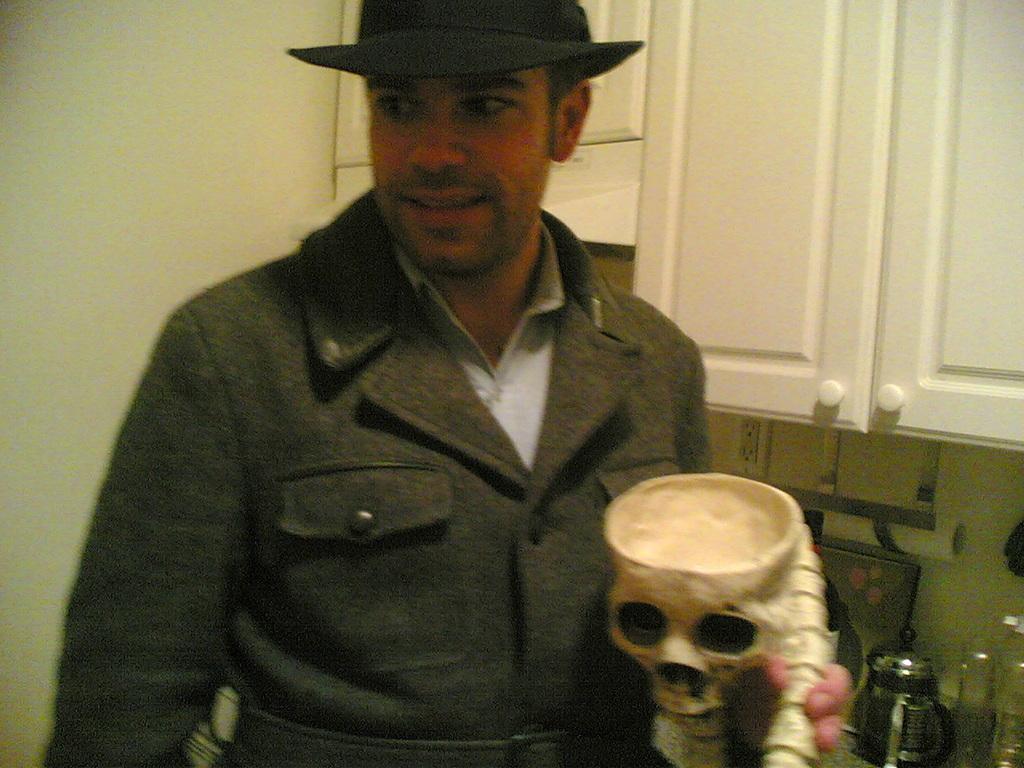In one or two sentences, can you explain what this image depicts? This image is taken indoors. In the background there are a wall and there are a few cupboards. In the middle of the image there is a man and he is holding a toy skull in his hand. On the right side of the image there is a kitchen platform with a few things on it. 